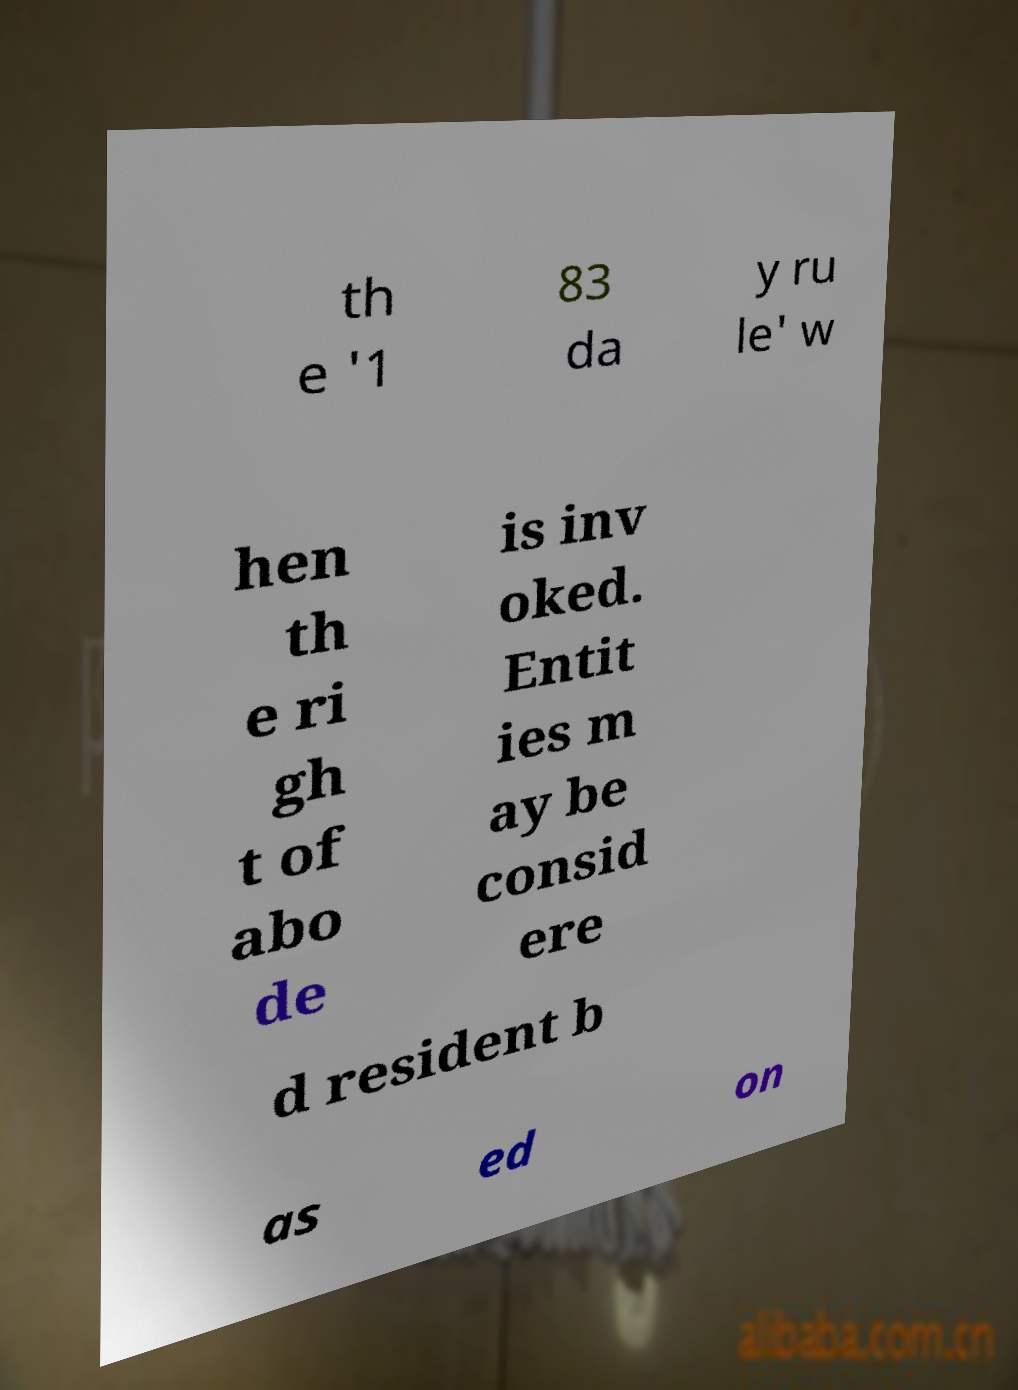Can you read and provide the text displayed in the image?This photo seems to have some interesting text. Can you extract and type it out for me? th e '1 83 da y ru le' w hen th e ri gh t of abo de is inv oked. Entit ies m ay be consid ere d resident b as ed on 